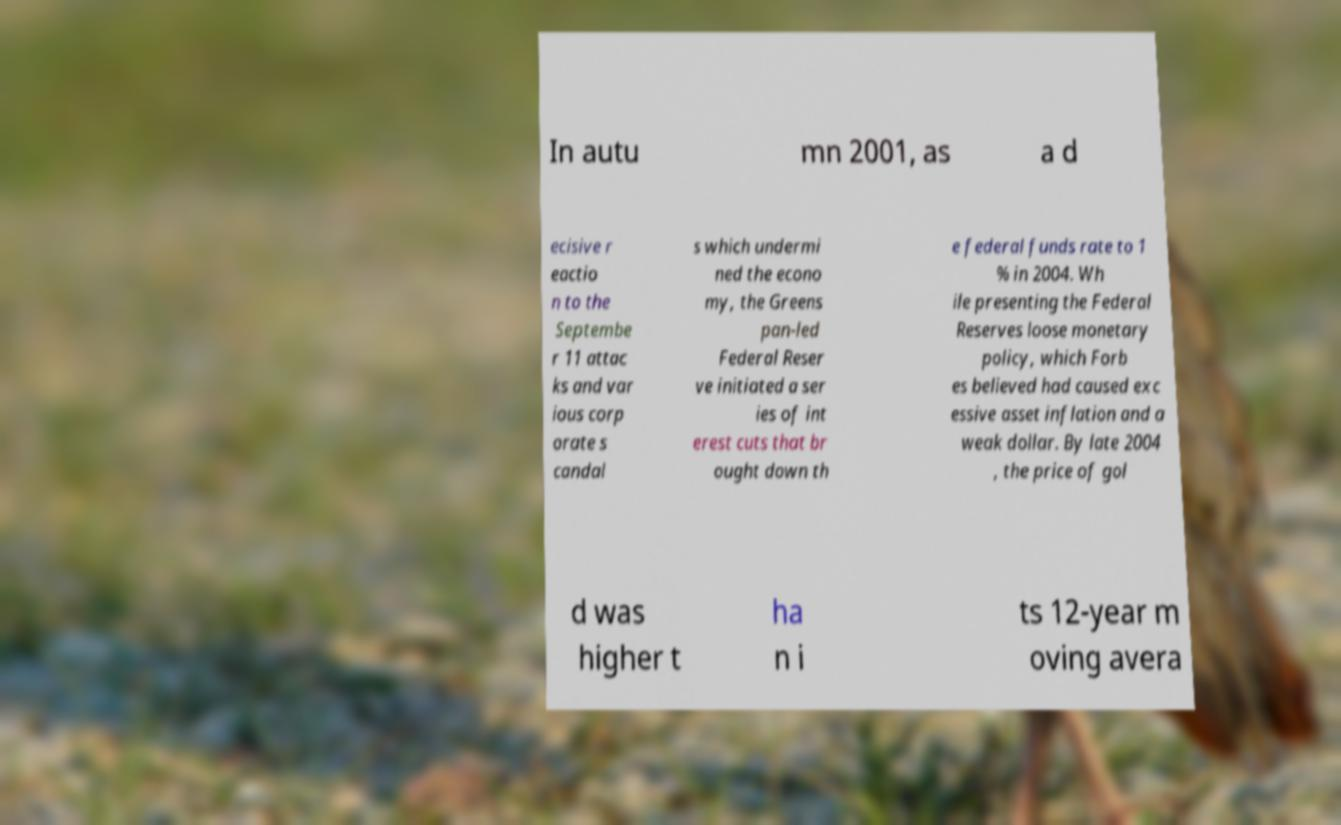Could you extract and type out the text from this image? In autu mn 2001, as a d ecisive r eactio n to the Septembe r 11 attac ks and var ious corp orate s candal s which undermi ned the econo my, the Greens pan-led Federal Reser ve initiated a ser ies of int erest cuts that br ought down th e federal funds rate to 1 % in 2004. Wh ile presenting the Federal Reserves loose monetary policy, which Forb es believed had caused exc essive asset inflation and a weak dollar. By late 2004 , the price of gol d was higher t ha n i ts 12-year m oving avera 